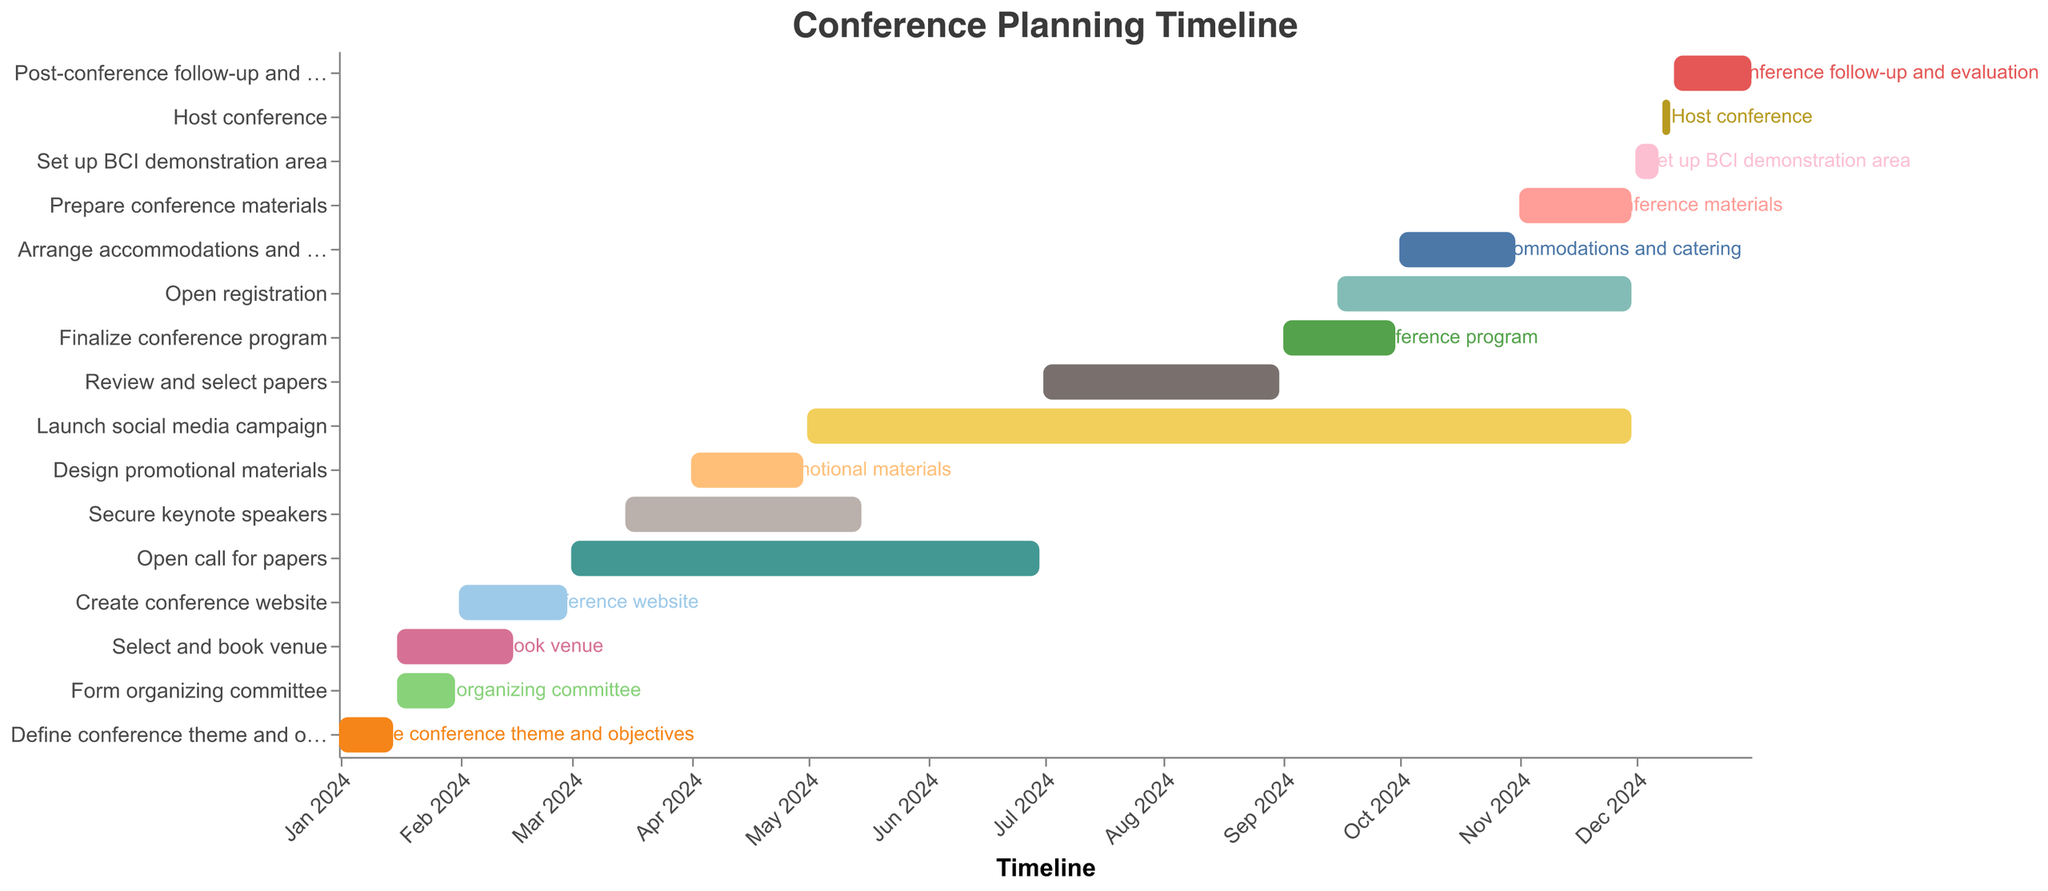What is the title of the Gantt Chart? The title of the Gantt chart is located at the top and indicates the main focus of the timeline. Here, it reads "Conference Planning Timeline."
Answer: Conference Planning Timeline When does the "Select and book venue" task start and end? By examining the color-coded bars and the respective dates on the timeline, it shows that the "Select and book venue" task starts on January 16, 2024, and ends on February 15, 2024.
Answer: January 16, 2024 - February 15, 2024 Which task has the longest duration? To find the task with the longest duration, look for the bar that spans the most days on the timeline. The "Launch social media campaign" task starts on May 1, 2024, and ends on November 30, 2024, making it the longest.
Answer: Launch social media campaign How many tasks start in January 2024? Count the tasks with a "Start Date" in January 2024. There are four tasks that start in January: "Define conference theme and objectives," "Select and book venue," "Form organizing committee," and "Create conference website."
Answer: 4 Which tasks are ongoing during the month of June 2024? Examine the tasks that include June 2024 within their start and end dates. These tasks are "Open call for papers" and "Secure keynote speakers."
Answer: Open call for papers and Secure keynote speakers What is the duration of the "Host conference" task? Calculate the duration by subtracting the start date from the end date. The "Host conference" task starts on December 8, 2024, and ends on December 10, 2024, lasting 3 days.
Answer: 3 days Which two tasks overlap the "Review and select papers" task? Identify tasks that share any date range with "Review and select papers" (July 1, 2024 - August 31, 2024). The overlapping tasks are "Launch social media campaign" and "Secure keynote speakers."
Answer: Launch social media campaign and Secure keynote speakers When does the “Finalize conference program” task start and end? Locate the "Finalize conference program" task and note its corresponding dates on the timeline. It starts on September 1, 2024, and ends on September 30, 2024.
Answer: September 1, 2024 - September 30, 2024 Which task immediately follows the "Set up BCI demonstration area"? Identify the task that starts right after the end date of "Set up BCI demonstration area." "Host conference" starts immediately after on December 8, 2024.
Answer: Host conference What is the total duration from the start of the earliest task to the end of the last task? Calculate the difference from the earliest start date (January 1, 2024) to the latest end date (December 31, 2024). This span covers 365 days in 2024.
Answer: 365 days 